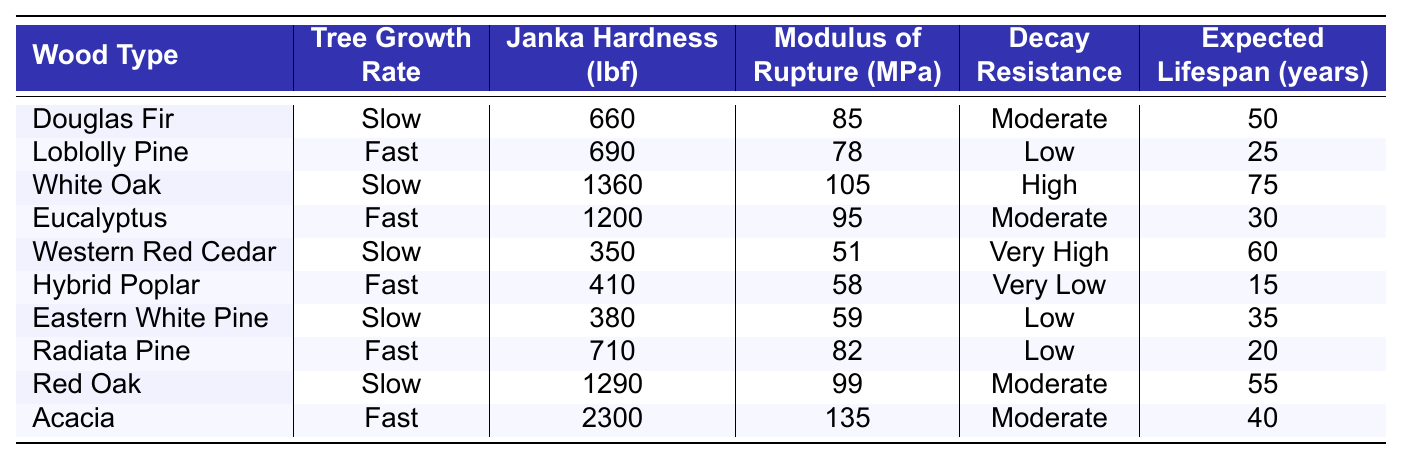What is the Janka Hardness of White Oak? The table lists White Oak under the "Wood Type" column, showing its associated Janka Hardness as 1360 lbf.
Answer: 1360 lbf Which wood type has the highest expected lifespan? Looking at the "Expected Lifespan (years)" column, White Oak shows the highest expected lifespan of 75 years compared to other entries.
Answer: 75 years Is Loblolly Pine's Modulus of Rupture greater than that of Hybrid Poplar? The table has Loblolly Pine's Modulus of Rupture as 78 MPa and Hybrid Poplar's as 58 MPa. Since 78 > 58, Loblolly Pine does have a greater value.
Answer: Yes What is the average Janka Hardness of fast-growing trees? The Janka Hardness values for fast-growing trees are 690, 1200, 410, 710, and 2300. Adding these gives 690 + 1200 + 410 + 710 + 2300 = 5310. Dividing by the 5 trees gives an average of 5310 / 5 = 1062.
Answer: 1062 lbf Which slow-growing wood has the lowest decay resistance rating? The decay resistance ratings for slow-growing woods are Moderate (Douglas Fir), High (White Oak), Very High (Western Red Cedar), Low (Eastern White Pine), and Moderate (Red Oak). The lowest rating is Low for Eastern White Pine.
Answer: Eastern White Pine Does any fast-growing wood type meet or exceed the decay resistance of slow-growing wood? Decay resistance for fast-growing woods are Low (Loblolly Pine), Moderate (Eucalyptus), Very Low (Hybrid Poplar), Low (Radiata Pine), and Moderate (Acacia). All are either Low or Very Low, so none meet or exceed the Moderate rating from slow-growing woods.
Answer: No Which wood type is the most durable according to the Janka Hardness? The highest Janka Hardness value is 2300 for Acacia, making it the most durable wood type listed in the table.
Answer: Acacia If we were to compare the average expected lifespan of slow-growing trees to fast-growing ones, what would the result be? Slow-growing expected lifespans are 50, 75, 60, 35, and 55 resulting in an average of (50 + 75 + 60 + 35 + 55) / 5 = 55. Fast-growing expected lifespans are 25, 30, 15, 20, and 40 leading to an average of (25 + 30 + 15 + 20 + 40) / 5 = 26. This means slow-growing trees have a higher average lifespan.
Answer: Slow-growing trees have a higher average lifespan Which wood type has both the highest Janka Hardness and the longest expected lifespan? Looking at the Janka Hardness and Expected Lifespan, White Oak has the highest hardness (1360 lbf) and an expected lifespan of 75 years, which are both the highest values in their respective categories among slow-growing types.
Answer: White Oak 